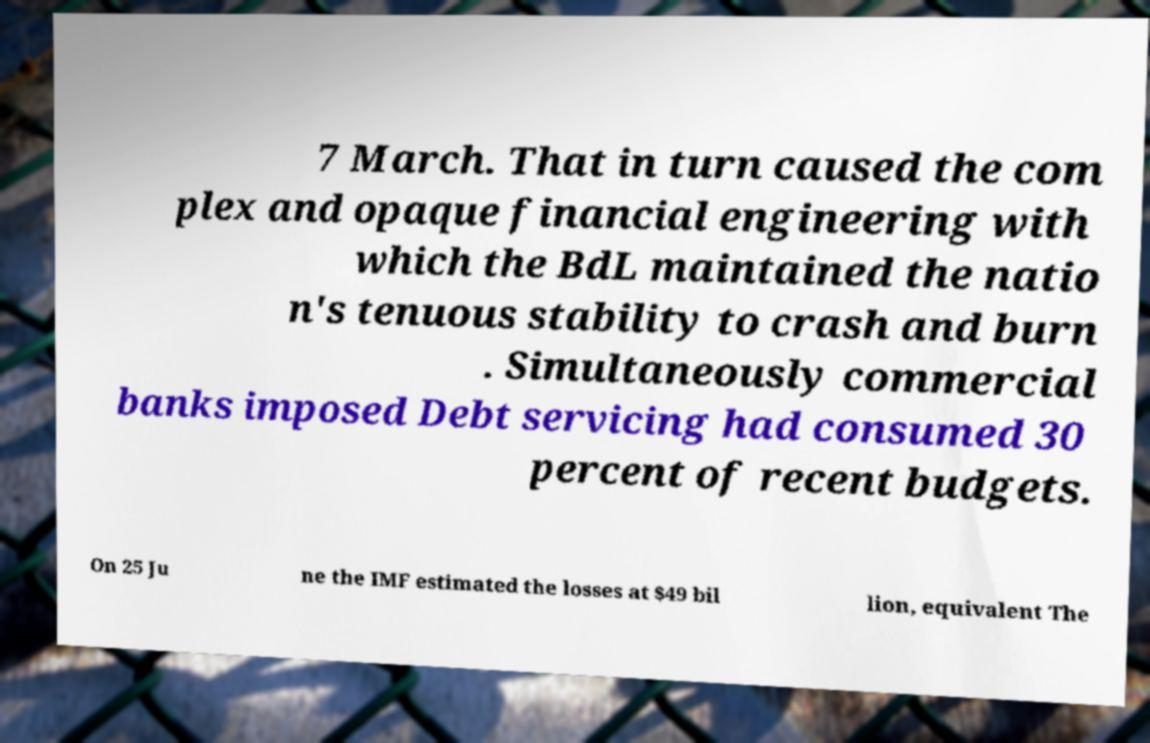Could you extract and type out the text from this image? 7 March. That in turn caused the com plex and opaque financial engineering with which the BdL maintained the natio n's tenuous stability to crash and burn . Simultaneously commercial banks imposed Debt servicing had consumed 30 percent of recent budgets. On 25 Ju ne the IMF estimated the losses at $49 bil lion, equivalent The 